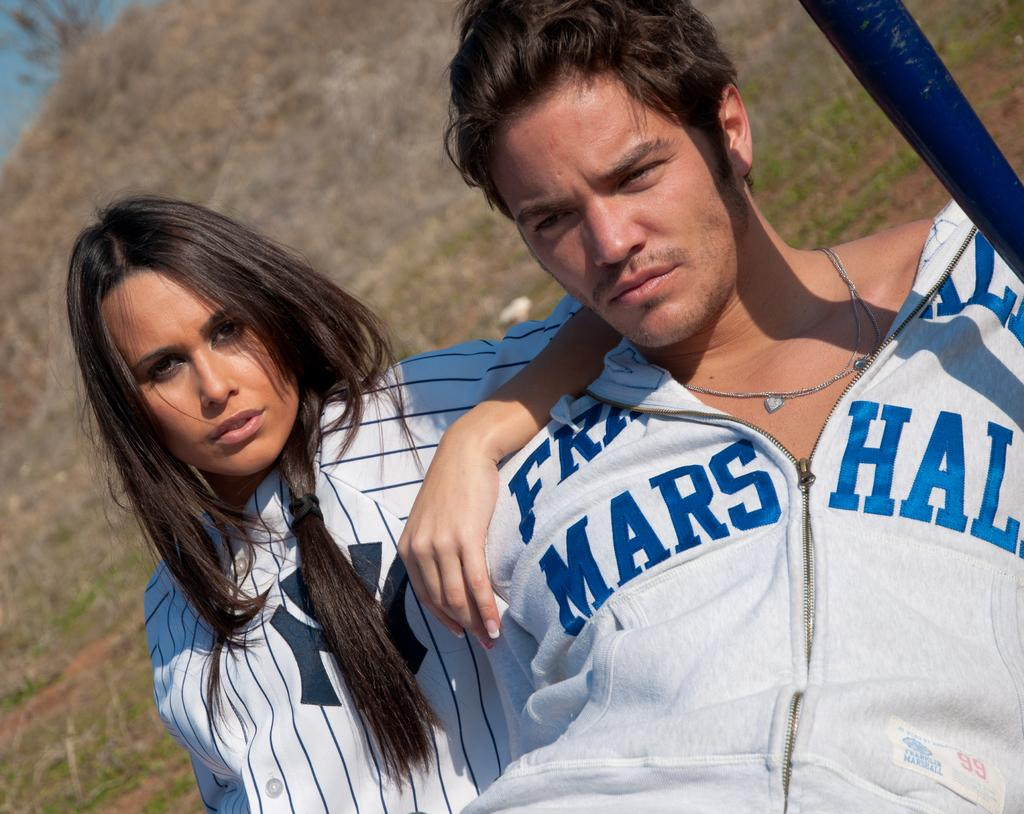How many people are in the image? There is a man and a woman in the image. What colors can be seen in the image? There is a blue object in the top right of the image, and sky is visible in the top left of the image. What is the background of the image? Grass is visible behind the persons in the image. How many weeks does the hammer have in the image? There is no hammer present in the image. What is the height of the low object in the image? There is no low object present in the image. 